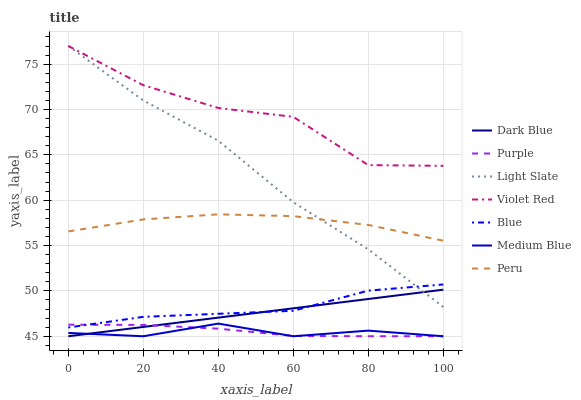Does Medium Blue have the minimum area under the curve?
Answer yes or no. Yes. Does Violet Red have the maximum area under the curve?
Answer yes or no. Yes. Does Purple have the minimum area under the curve?
Answer yes or no. No. Does Purple have the maximum area under the curve?
Answer yes or no. No. Is Dark Blue the smoothest?
Answer yes or no. Yes. Is Violet Red the roughest?
Answer yes or no. Yes. Is Purple the smoothest?
Answer yes or no. No. Is Purple the roughest?
Answer yes or no. No. Does Violet Red have the lowest value?
Answer yes or no. No. Does Light Slate have the highest value?
Answer yes or no. Yes. Does Purple have the highest value?
Answer yes or no. No. Is Blue less than Peru?
Answer yes or no. Yes. Is Blue greater than Medium Blue?
Answer yes or no. Yes. Does Dark Blue intersect Purple?
Answer yes or no. Yes. Is Dark Blue less than Purple?
Answer yes or no. No. Is Dark Blue greater than Purple?
Answer yes or no. No. Does Blue intersect Peru?
Answer yes or no. No. 